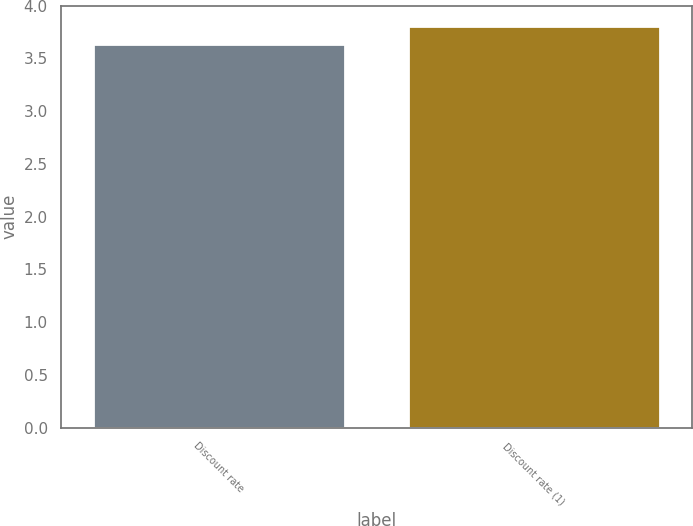<chart> <loc_0><loc_0><loc_500><loc_500><bar_chart><fcel>Discount rate<fcel>Discount rate (1)<nl><fcel>3.64<fcel>3.81<nl></chart> 